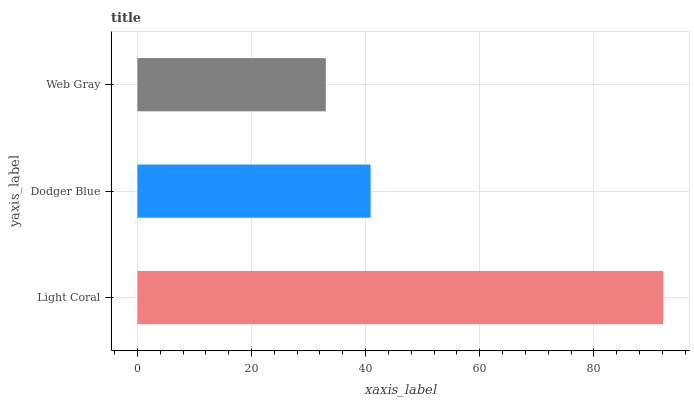Is Web Gray the minimum?
Answer yes or no. Yes. Is Light Coral the maximum?
Answer yes or no. Yes. Is Dodger Blue the minimum?
Answer yes or no. No. Is Dodger Blue the maximum?
Answer yes or no. No. Is Light Coral greater than Dodger Blue?
Answer yes or no. Yes. Is Dodger Blue less than Light Coral?
Answer yes or no. Yes. Is Dodger Blue greater than Light Coral?
Answer yes or no. No. Is Light Coral less than Dodger Blue?
Answer yes or no. No. Is Dodger Blue the high median?
Answer yes or no. Yes. Is Dodger Blue the low median?
Answer yes or no. Yes. Is Web Gray the high median?
Answer yes or no. No. Is Light Coral the low median?
Answer yes or no. No. 